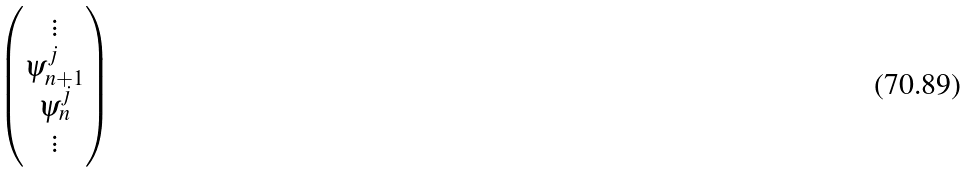<formula> <loc_0><loc_0><loc_500><loc_500>\begin{pmatrix} \vdots \\ \psi ^ { j } _ { n + 1 } \\ \psi ^ { j } _ { n } \\ \vdots \end{pmatrix}</formula> 